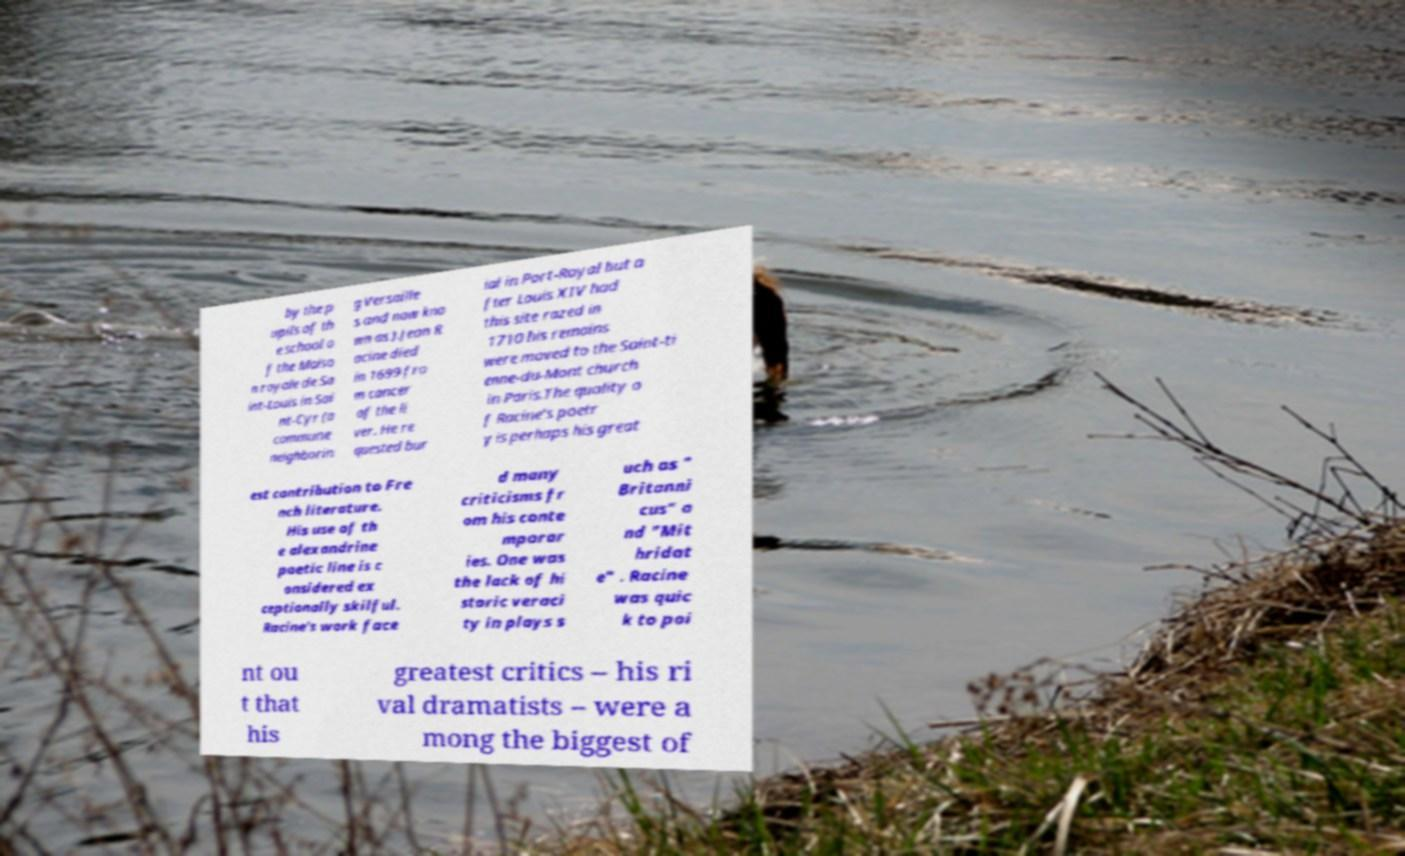Could you extract and type out the text from this image? by the p upils of th e school o f the Maiso n royale de Sa int-Louis in Sai nt-Cyr (a commune neighborin g Versaille s and now kno wn as ).Jean R acine died in 1699 fro m cancer of the li ver. He re quested bur ial in Port-Royal but a fter Louis XIV had this site razed in 1710 his remains were moved to the Saint-ti enne-du-Mont church in Paris.The quality o f Racine's poetr y is perhaps his great est contribution to Fre nch literature. His use of th e alexandrine poetic line is c onsidered ex ceptionally skilful. Racine's work face d many criticisms fr om his conte mporar ies. One was the lack of hi storic veraci ty in plays s uch as " Britanni cus" a nd "Mit hridat e" . Racine was quic k to poi nt ou t that his greatest critics – his ri val dramatists – were a mong the biggest of 